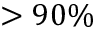Convert formula to latex. <formula><loc_0><loc_0><loc_500><loc_500>> 9 0 \%</formula> 